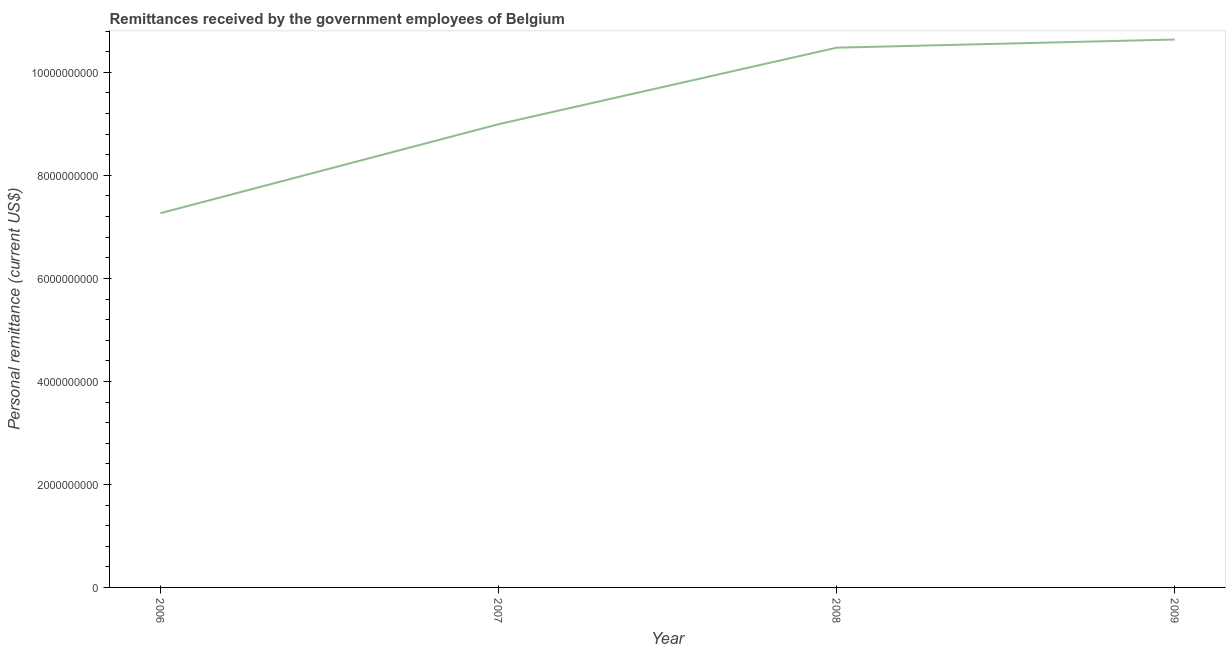What is the personal remittances in 2006?
Make the answer very short. 7.27e+09. Across all years, what is the maximum personal remittances?
Offer a terse response. 1.06e+1. Across all years, what is the minimum personal remittances?
Provide a succinct answer. 7.27e+09. In which year was the personal remittances maximum?
Your answer should be compact. 2009. In which year was the personal remittances minimum?
Your answer should be very brief. 2006. What is the sum of the personal remittances?
Make the answer very short. 3.74e+1. What is the difference between the personal remittances in 2006 and 2009?
Offer a terse response. -3.37e+09. What is the average personal remittances per year?
Provide a succinct answer. 9.34e+09. What is the median personal remittances?
Provide a short and direct response. 9.74e+09. What is the ratio of the personal remittances in 2008 to that in 2009?
Your response must be concise. 0.99. Is the personal remittances in 2007 less than that in 2008?
Your answer should be compact. Yes. What is the difference between the highest and the second highest personal remittances?
Give a very brief answer. 1.59e+08. Is the sum of the personal remittances in 2007 and 2009 greater than the maximum personal remittances across all years?
Give a very brief answer. Yes. What is the difference between the highest and the lowest personal remittances?
Make the answer very short. 3.37e+09. Does the personal remittances monotonically increase over the years?
Ensure brevity in your answer.  Yes. What is the difference between two consecutive major ticks on the Y-axis?
Offer a very short reply. 2.00e+09. Does the graph contain any zero values?
Give a very brief answer. No. What is the title of the graph?
Your answer should be compact. Remittances received by the government employees of Belgium. What is the label or title of the Y-axis?
Ensure brevity in your answer.  Personal remittance (current US$). What is the Personal remittance (current US$) of 2006?
Give a very brief answer. 7.27e+09. What is the Personal remittance (current US$) in 2007?
Offer a very short reply. 8.99e+09. What is the Personal remittance (current US$) in 2008?
Provide a succinct answer. 1.05e+1. What is the Personal remittance (current US$) in 2009?
Provide a short and direct response. 1.06e+1. What is the difference between the Personal remittance (current US$) in 2006 and 2007?
Offer a terse response. -1.73e+09. What is the difference between the Personal remittance (current US$) in 2006 and 2008?
Your answer should be compact. -3.21e+09. What is the difference between the Personal remittance (current US$) in 2006 and 2009?
Your response must be concise. -3.37e+09. What is the difference between the Personal remittance (current US$) in 2007 and 2008?
Keep it short and to the point. -1.49e+09. What is the difference between the Personal remittance (current US$) in 2007 and 2009?
Keep it short and to the point. -1.64e+09. What is the difference between the Personal remittance (current US$) in 2008 and 2009?
Make the answer very short. -1.59e+08. What is the ratio of the Personal remittance (current US$) in 2006 to that in 2007?
Your response must be concise. 0.81. What is the ratio of the Personal remittance (current US$) in 2006 to that in 2008?
Your answer should be compact. 0.69. What is the ratio of the Personal remittance (current US$) in 2006 to that in 2009?
Ensure brevity in your answer.  0.68. What is the ratio of the Personal remittance (current US$) in 2007 to that in 2008?
Give a very brief answer. 0.86. What is the ratio of the Personal remittance (current US$) in 2007 to that in 2009?
Ensure brevity in your answer.  0.84. 